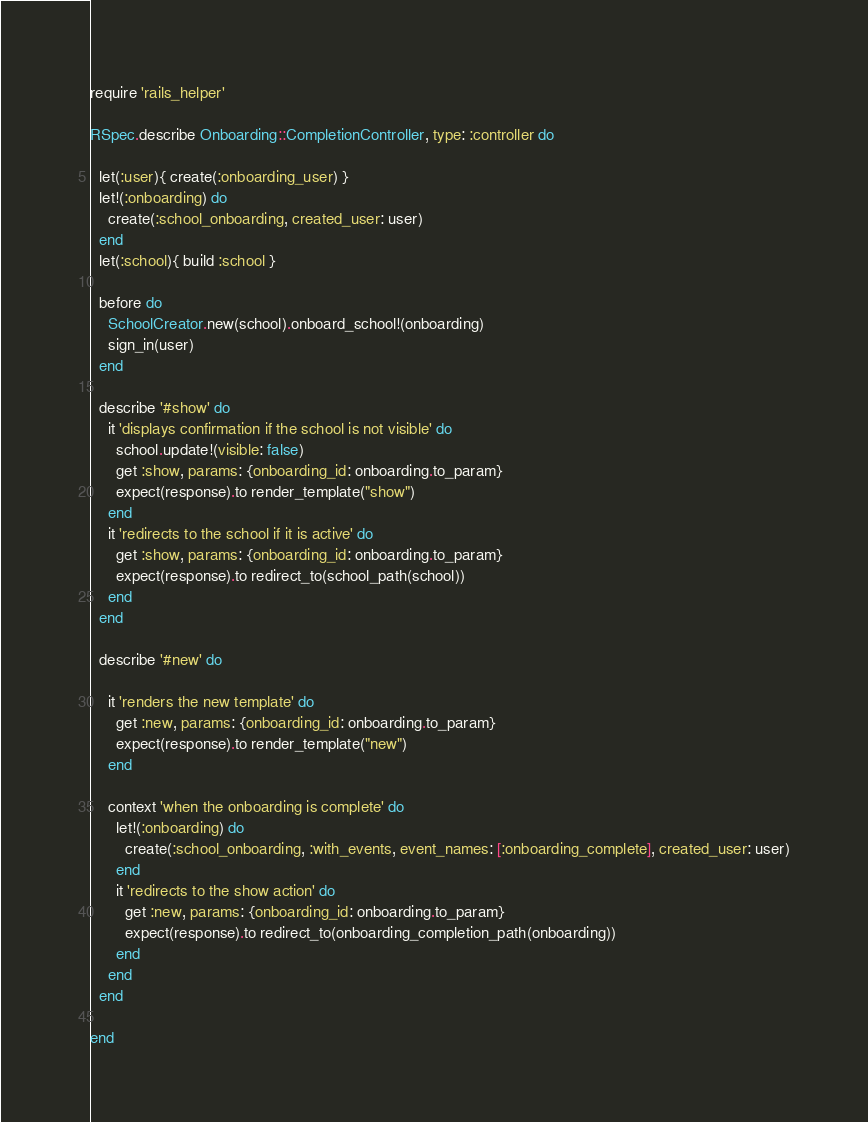Convert code to text. <code><loc_0><loc_0><loc_500><loc_500><_Ruby_>require 'rails_helper'

RSpec.describe Onboarding::CompletionController, type: :controller do

  let(:user){ create(:onboarding_user) }
  let!(:onboarding) do
    create(:school_onboarding, created_user: user)
  end
  let(:school){ build :school }

  before do
    SchoolCreator.new(school).onboard_school!(onboarding)
    sign_in(user)
  end

  describe '#show' do
    it 'displays confirmation if the school is not visible' do
      school.update!(visible: false)
      get :show, params: {onboarding_id: onboarding.to_param}
      expect(response).to render_template("show")
    end
    it 'redirects to the school if it is active' do
      get :show, params: {onboarding_id: onboarding.to_param}
      expect(response).to redirect_to(school_path(school))
    end
  end

  describe '#new' do

    it 'renders the new template' do
      get :new, params: {onboarding_id: onboarding.to_param}
      expect(response).to render_template("new")
    end

    context 'when the onboarding is complete' do
      let!(:onboarding) do
        create(:school_onboarding, :with_events, event_names: [:onboarding_complete], created_user: user)
      end
      it 'redirects to the show action' do
        get :new, params: {onboarding_id: onboarding.to_param}
        expect(response).to redirect_to(onboarding_completion_path(onboarding))
      end
    end
  end

end
</code> 